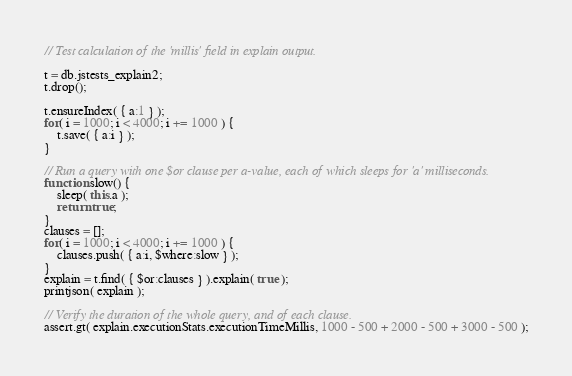Convert code to text. <code><loc_0><loc_0><loc_500><loc_500><_JavaScript_>// Test calculation of the 'millis' field in explain output.

t = db.jstests_explain2;
t.drop();

t.ensureIndex( { a:1 } );
for( i = 1000; i < 4000; i += 1000 ) {
    t.save( { a:i } );
}

// Run a query with one $or clause per a-value, each of which sleeps for 'a' milliseconds.
function slow() {
    sleep( this.a );
    return true;
}
clauses = [];
for( i = 1000; i < 4000; i += 1000 ) {
    clauses.push( { a:i, $where:slow } );
}
explain = t.find( { $or:clauses } ).explain( true );
printjson( explain );

// Verify the duration of the whole query, and of each clause.
assert.gt( explain.executionStats.executionTimeMillis, 1000 - 500 + 2000 - 500 + 3000 - 500 );
</code> 